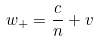<formula> <loc_0><loc_0><loc_500><loc_500>w _ { + } = \frac { c } { n } + v</formula> 